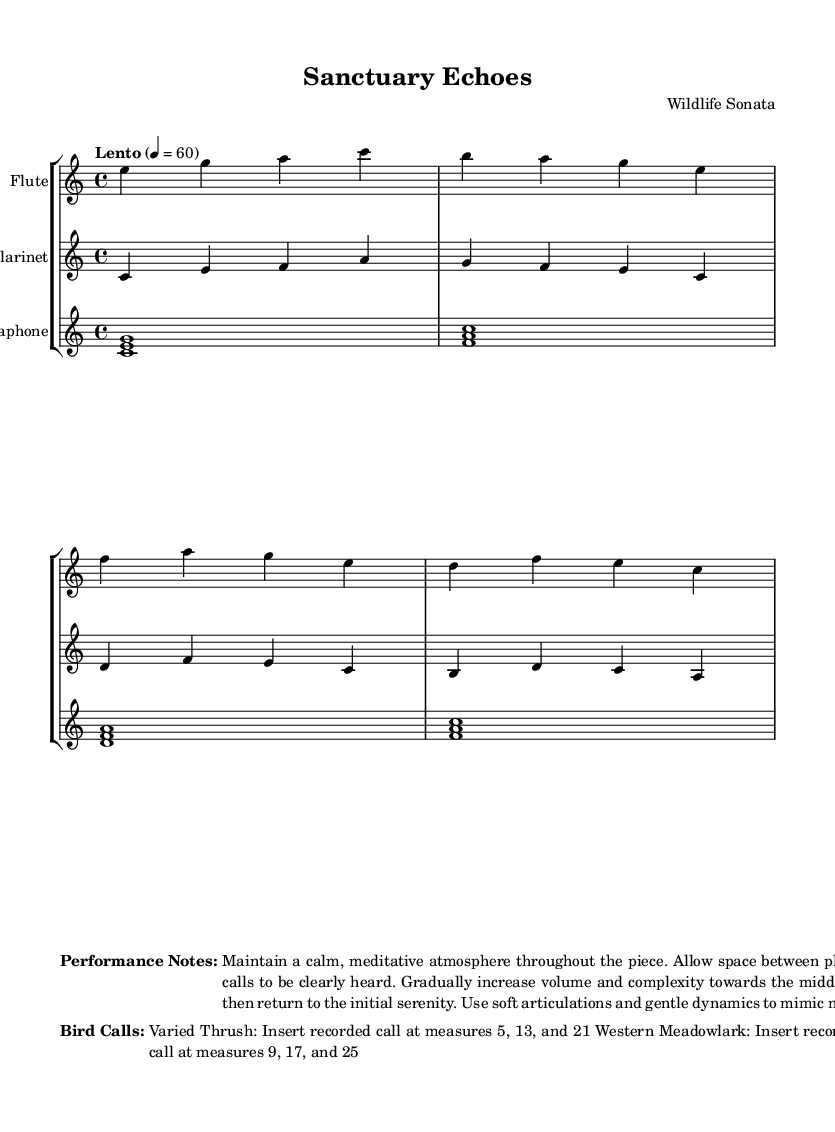What is the key signature of this music? The key signature shown in the music indicates C major, which has no sharps or flats.
Answer: C major What is the time signature of this piece? The time signature indicated in the music is 4/4, meaning there are four beats in each measure.
Answer: 4/4 What is the tempo marking of this composition? The tempo marking in the score specifies "Lento," which indicates a slow pace of 60 beats per minute.
Answer: Lento What instruments are featured in this composition? The score lists three instruments: Flute, Clarinet, and Vibraphone, which are all presented on separate staves.
Answer: Flute, Clarinet, Vibraphone At which measures should the Varied Thrush call be inserted? The performance notes specify that the Varied Thrush call should be inserted at measures 5, 13, and 21, which indicates specific points to enhance the composition.
Answer: Measures 5, 13, 21 How does the dynamic change throughout the piece? The performance notes indicate that the dynamics should gradually increase and then return to serenity, showing a contrast between the initial calmness and a middle section with more complexity.
Answer: Gradually increase and return to serenity What is the overall mood intended for this piece? The performance notes suggest a calm, meditative atmosphere should be maintained throughout, indicating the desired emotional effect of the music.
Answer: Calm, meditative atmosphere 